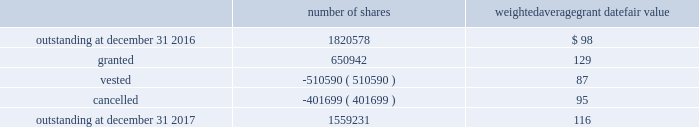In 2017 , the company granted 440076 shares of restricted class a common stock and 7568 shares of restricted stock units .
Restricted common stock and restricted stock units generally have a vesting period of two to four years .
The fair value related to these grants was $ 58.7 million , which is recognized as compensation expense on an accelerated basis over the vesting period .
Dividends are accrued on restricted class a common stock and restricted stock units and are paid once the restricted stock vests .
In 2017 , the company also granted 203298 performance shares .
The fair value related to these grants was $ 25.3 million , which is recognized as compensation expense on an accelerated and straight-lined basis over the vesting period .
The vesting of these shares is contingent on meeting stated performance or market conditions .
The table summarizes restricted stock , restricted stock units , and performance shares activity for 2017 : number of shares weighted average grant date fair value .
The total fair value of restricted stock , restricted stock units , and performance shares that vested during 2017 , 2016 and 2015 was $ 66.0 million , $ 59.8 million and $ 43.3 million , respectively .
Under the espp , eligible employees may acquire shares of class a common stock using after-tax payroll deductions made during consecutive offering periods of approximately six months in duration .
Shares are purchased at the end of each offering period at a price of 90% ( 90 % ) of the closing price of the class a common stock as reported on the nasdaq global select market .
Compensation expense is recognized on the dates of purchase for the discount from the closing price .
In 2017 , 2016 and 2015 , a total of 19936 , 19858 and 19756 shares , respectively , of class a common stock were issued to participating employees .
These shares are subject to a six-month holding period .
Annual expense of $ 0.3 million for the purchase discount was recognized in 2017 , and $ 0.2 million was recognized in both 2016 and 2015 .
Non-executive directors receive an annual award of class a common stock with a value equal to $ 100000 .
Non-executive directors may also elect to receive some or all of the cash portion of their annual stipend , up to $ 60000 , in shares of stock based on the closing price at the date of distribution .
As a result , 19736 shares , 26439 shares and 25853 shares of class a common stock were issued to non-executive directors during 2017 , 2016 and 2015 , respectively .
These shares are not subject to any vesting restrictions .
Expense of $ 2.5 million , $ 2.4 million and $ 2.5 million related to these stock-based payments was recognized for the years ended december 31 , 2017 , 2016 and 2015 , respectively. .
What was the sum of the shares purchase discount from 2015 to 2017 in millions? 
Computations: ((0.3 + 0.2) + 0.2)
Answer: 0.7. In 2017 , the company granted 440076 shares of restricted class a common stock and 7568 shares of restricted stock units .
Restricted common stock and restricted stock units generally have a vesting period of two to four years .
The fair value related to these grants was $ 58.7 million , which is recognized as compensation expense on an accelerated basis over the vesting period .
Dividends are accrued on restricted class a common stock and restricted stock units and are paid once the restricted stock vests .
In 2017 , the company also granted 203298 performance shares .
The fair value related to these grants was $ 25.3 million , which is recognized as compensation expense on an accelerated and straight-lined basis over the vesting period .
The vesting of these shares is contingent on meeting stated performance or market conditions .
The table summarizes restricted stock , restricted stock units , and performance shares activity for 2017 : number of shares weighted average grant date fair value .
The total fair value of restricted stock , restricted stock units , and performance shares that vested during 2017 , 2016 and 2015 was $ 66.0 million , $ 59.8 million and $ 43.3 million , respectively .
Under the espp , eligible employees may acquire shares of class a common stock using after-tax payroll deductions made during consecutive offering periods of approximately six months in duration .
Shares are purchased at the end of each offering period at a price of 90% ( 90 % ) of the closing price of the class a common stock as reported on the nasdaq global select market .
Compensation expense is recognized on the dates of purchase for the discount from the closing price .
In 2017 , 2016 and 2015 , a total of 19936 , 19858 and 19756 shares , respectively , of class a common stock were issued to participating employees .
These shares are subject to a six-month holding period .
Annual expense of $ 0.3 million for the purchase discount was recognized in 2017 , and $ 0.2 million was recognized in both 2016 and 2015 .
Non-executive directors receive an annual award of class a common stock with a value equal to $ 100000 .
Non-executive directors may also elect to receive some or all of the cash portion of their annual stipend , up to $ 60000 , in shares of stock based on the closing price at the date of distribution .
As a result , 19736 shares , 26439 shares and 25853 shares of class a common stock were issued to non-executive directors during 2017 , 2016 and 2015 , respectively .
These shares are not subject to any vesting restrictions .
Expense of $ 2.5 million , $ 2.4 million and $ 2.5 million related to these stock-based payments was recognized for the years ended december 31 , 2017 , 2016 and 2015 , respectively. .
Considering the class a common stocks , what is the percentage's increase of the number issued to participating employees in relation non-executive directors amidst 2016 and 2017? 
Rationale: considering the class a common stocks issued between 2016 and 2017 , the ratio of the variation of stocks issued to employees and non directors is calculated dividing the number of shares issued in 2017 by the number issued in 2016 , then dividing both results .
Computations: (((19936 / 19858) / (19736 / 26439)) - 1)
Answer: 0.3449. In 2017 , the company granted 440076 shares of restricted class a common stock and 7568 shares of restricted stock units .
Restricted common stock and restricted stock units generally have a vesting period of two to four years .
The fair value related to these grants was $ 58.7 million , which is recognized as compensation expense on an accelerated basis over the vesting period .
Dividends are accrued on restricted class a common stock and restricted stock units and are paid once the restricted stock vests .
In 2017 , the company also granted 203298 performance shares .
The fair value related to these grants was $ 25.3 million , which is recognized as compensation expense on an accelerated and straight-lined basis over the vesting period .
The vesting of these shares is contingent on meeting stated performance or market conditions .
The table summarizes restricted stock , restricted stock units , and performance shares activity for 2017 : number of shares weighted average grant date fair value .
The total fair value of restricted stock , restricted stock units , and performance shares that vested during 2017 , 2016 and 2015 was $ 66.0 million , $ 59.8 million and $ 43.3 million , respectively .
Under the espp , eligible employees may acquire shares of class a common stock using after-tax payroll deductions made during consecutive offering periods of approximately six months in duration .
Shares are purchased at the end of each offering period at a price of 90% ( 90 % ) of the closing price of the class a common stock as reported on the nasdaq global select market .
Compensation expense is recognized on the dates of purchase for the discount from the closing price .
In 2017 , 2016 and 2015 , a total of 19936 , 19858 and 19756 shares , respectively , of class a common stock were issued to participating employees .
These shares are subject to a six-month holding period .
Annual expense of $ 0.3 million for the purchase discount was recognized in 2017 , and $ 0.2 million was recognized in both 2016 and 2015 .
Non-executive directors receive an annual award of class a common stock with a value equal to $ 100000 .
Non-executive directors may also elect to receive some or all of the cash portion of their annual stipend , up to $ 60000 , in shares of stock based on the closing price at the date of distribution .
As a result , 19736 shares , 26439 shares and 25853 shares of class a common stock were issued to non-executive directors during 2017 , 2016 and 2015 , respectively .
These shares are not subject to any vesting restrictions .
Expense of $ 2.5 million , $ 2.4 million and $ 2.5 million related to these stock-based payments was recognized for the years ended december 31 , 2017 , 2016 and 2015 , respectively. .
In millions , how much compensation expense was attributable to directors in the years ended december 31 , 2015 through 2017? 
Computations: ((2.4 + 2.5) + 2.5)
Answer: 7.4. 